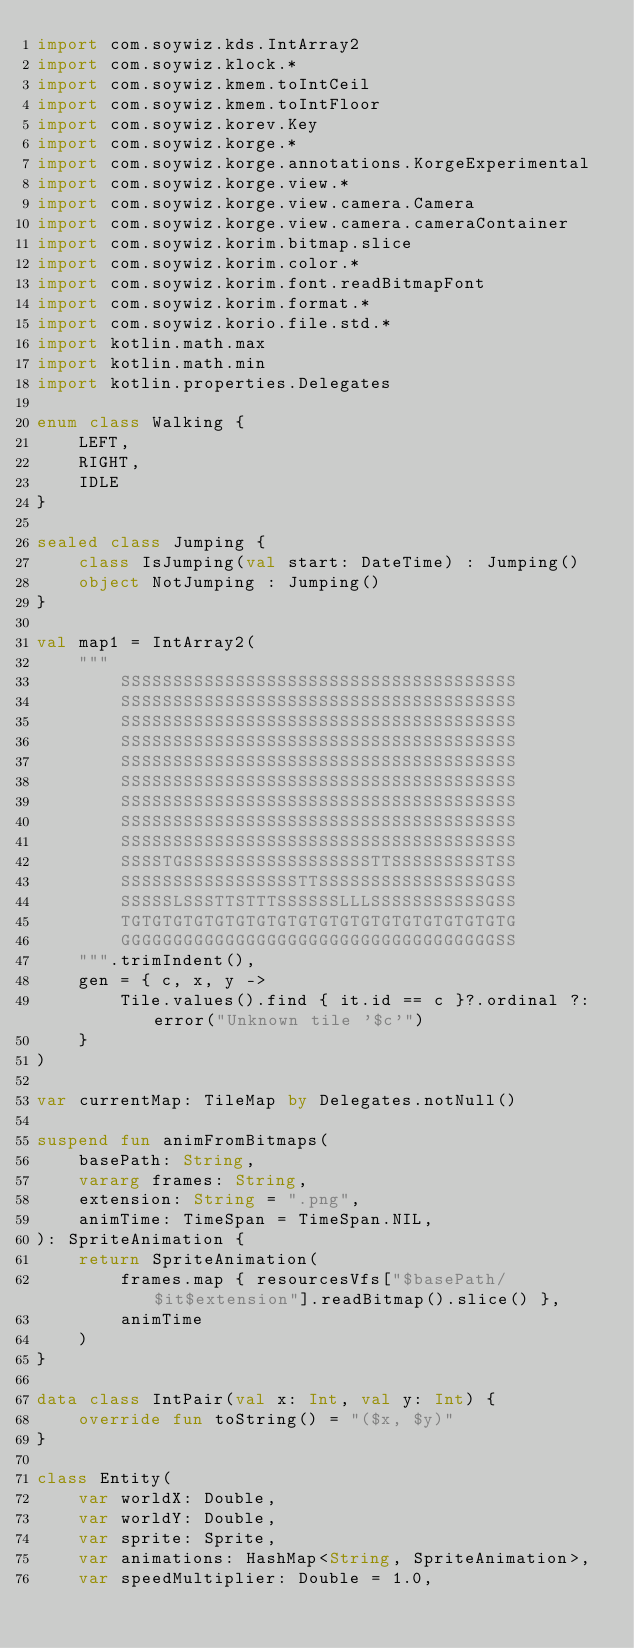<code> <loc_0><loc_0><loc_500><loc_500><_Kotlin_>import com.soywiz.kds.IntArray2
import com.soywiz.klock.*
import com.soywiz.kmem.toIntCeil
import com.soywiz.kmem.toIntFloor
import com.soywiz.korev.Key
import com.soywiz.korge.*
import com.soywiz.korge.annotations.KorgeExperimental
import com.soywiz.korge.view.*
import com.soywiz.korge.view.camera.Camera
import com.soywiz.korge.view.camera.cameraContainer
import com.soywiz.korim.bitmap.slice
import com.soywiz.korim.color.*
import com.soywiz.korim.font.readBitmapFont
import com.soywiz.korim.format.*
import com.soywiz.korio.file.std.*
import kotlin.math.max
import kotlin.math.min
import kotlin.properties.Delegates

enum class Walking {
    LEFT,
    RIGHT,
    IDLE
}

sealed class Jumping {
    class IsJumping(val start: DateTime) : Jumping()
    object NotJumping : Jumping()
}

val map1 = IntArray2(
    """
        SSSSSSSSSSSSSSSSSSSSSSSSSSSSSSSSSSSSSS
        SSSSSSSSSSSSSSSSSSSSSSSSSSSSSSSSSSSSSS
        SSSSSSSSSSSSSSSSSSSSSSSSSSSSSSSSSSSSSS
        SSSSSSSSSSSSSSSSSSSSSSSSSSSSSSSSSSSSSS
        SSSSSSSSSSSSSSSSSSSSSSSSSSSSSSSSSSSSSS
        SSSSSSSSSSSSSSSSSSSSSSSSSSSSSSSSSSSSSS
        SSSSSSSSSSSSSSSSSSSSSSSSSSSSSSSSSSSSSS
        SSSSSSSSSSSSSSSSSSSSSSSSSSSSSSSSSSSSSS
        SSSSSSSSSSSSSSSSSSSSSSSSSSSSSSSSSSSSSS
        SSSSTGSSSSSSSSSSSSSSSSSSTTSSSSSSSSSTSS
        SSSSSSSSSSSSSSSSSTTSSSSSSSSSSSSSSSSGSS
        SSSSSLSSSTTSTTTSSSSSSLLLSSSSSSSSSSSGSS
        TGTGTGTGTGTGTGTGTGTGTGTGTGTGTGTGTGTGTG
        GGGGGGGGGGGGGGGGGGGGGGGGGGGGGGGGGGGGSS
    """.trimIndent(),
    gen = { c, x, y ->
        Tile.values().find { it.id == c }?.ordinal ?: error("Unknown tile '$c'")
    }
)

var currentMap: TileMap by Delegates.notNull()

suspend fun animFromBitmaps(
    basePath: String,
    vararg frames: String,
    extension: String = ".png",
    animTime: TimeSpan = TimeSpan.NIL,
): SpriteAnimation {
    return SpriteAnimation(
        frames.map { resourcesVfs["$basePath/$it$extension"].readBitmap().slice() },
        animTime
    )
}

data class IntPair(val x: Int, val y: Int) {
    override fun toString() = "($x, $y)"
}

class Entity(
    var worldX: Double,
    var worldY: Double,
    var sprite: Sprite,
    var animations: HashMap<String, SpriteAnimation>,
    var speedMultiplier: Double = 1.0,</code> 